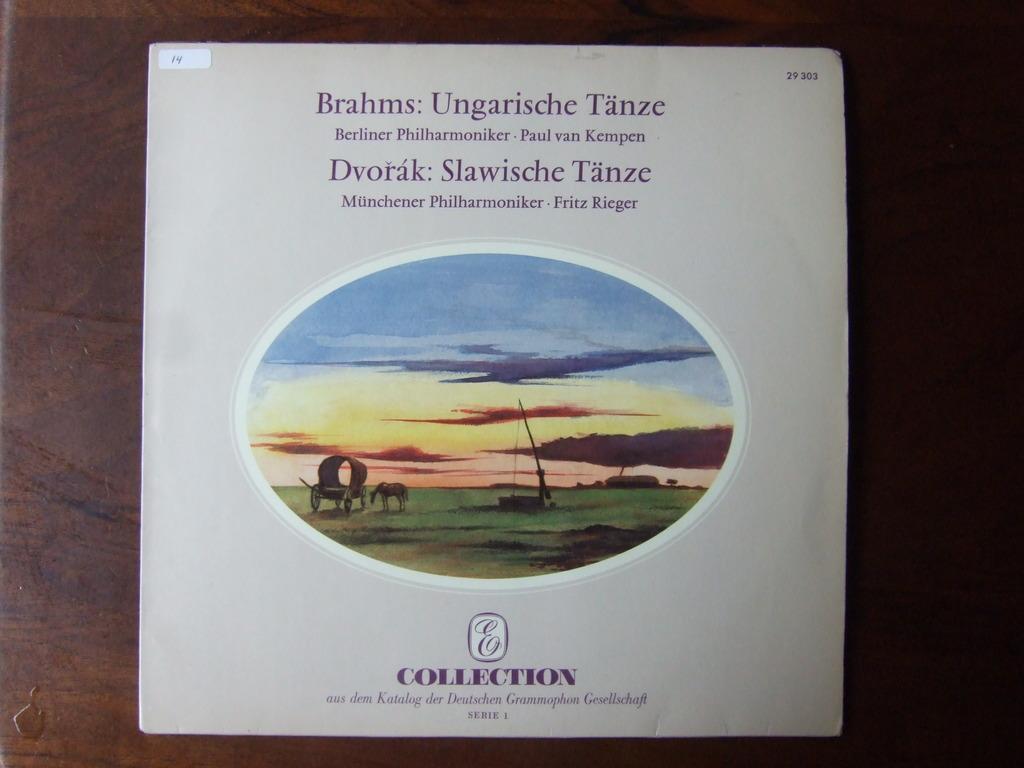What is the title of this album?
Offer a very short reply. Brahms: ungarische tanze. What is the number shown on the upper right hand corner?
Your answer should be compact. 29 303. 